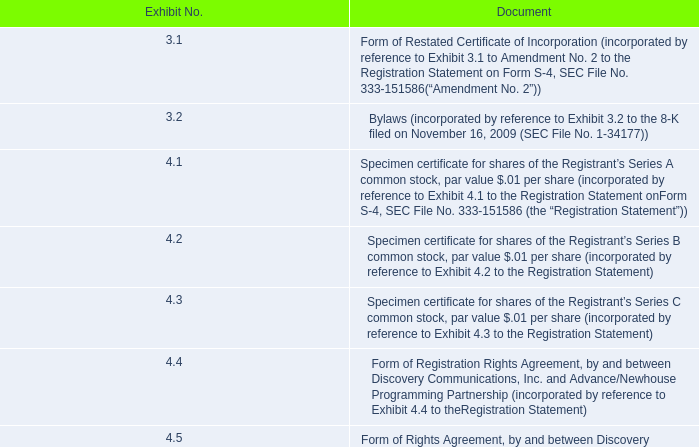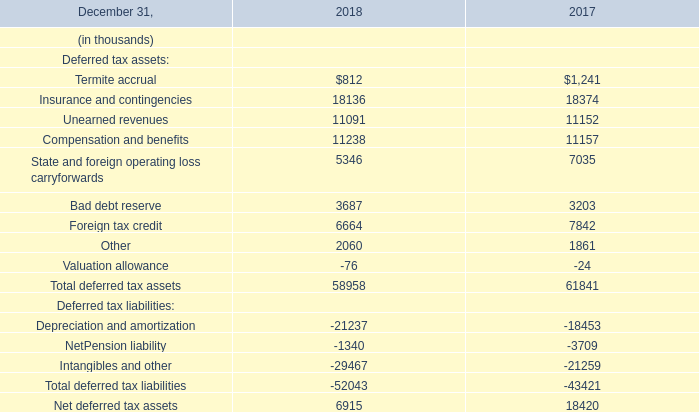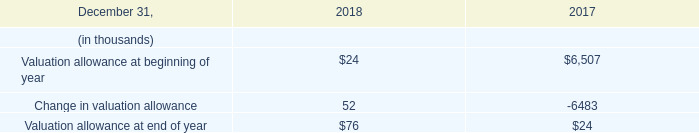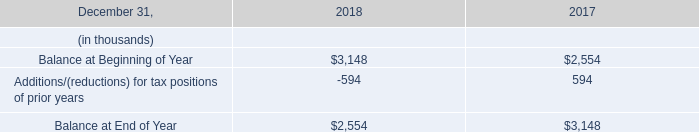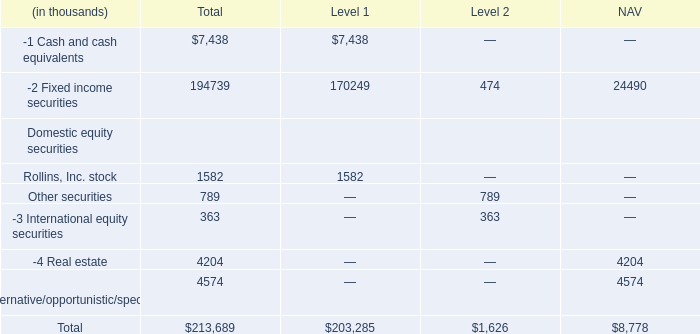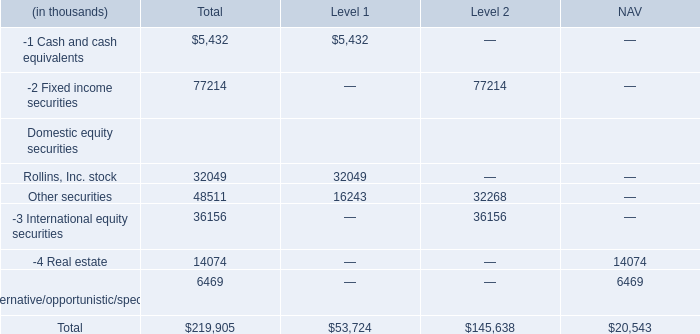As As the chart 4 shows,what is the value of the International equity securities in the Level where the value of Fixed income securities is the lowest? (in thousand) 
Answer: 363. 